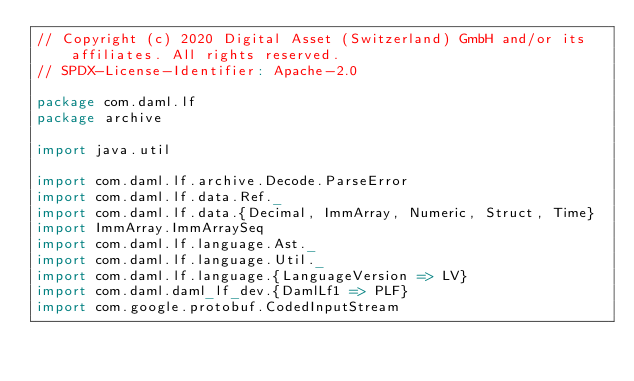<code> <loc_0><loc_0><loc_500><loc_500><_Scala_>// Copyright (c) 2020 Digital Asset (Switzerland) GmbH and/or its affiliates. All rights reserved.
// SPDX-License-Identifier: Apache-2.0

package com.daml.lf
package archive

import java.util

import com.daml.lf.archive.Decode.ParseError
import com.daml.lf.data.Ref._
import com.daml.lf.data.{Decimal, ImmArray, Numeric, Struct, Time}
import ImmArray.ImmArraySeq
import com.daml.lf.language.Ast._
import com.daml.lf.language.Util._
import com.daml.lf.language.{LanguageVersion => LV}
import com.daml.daml_lf_dev.{DamlLf1 => PLF}
import com.google.protobuf.CodedInputStream
</code> 